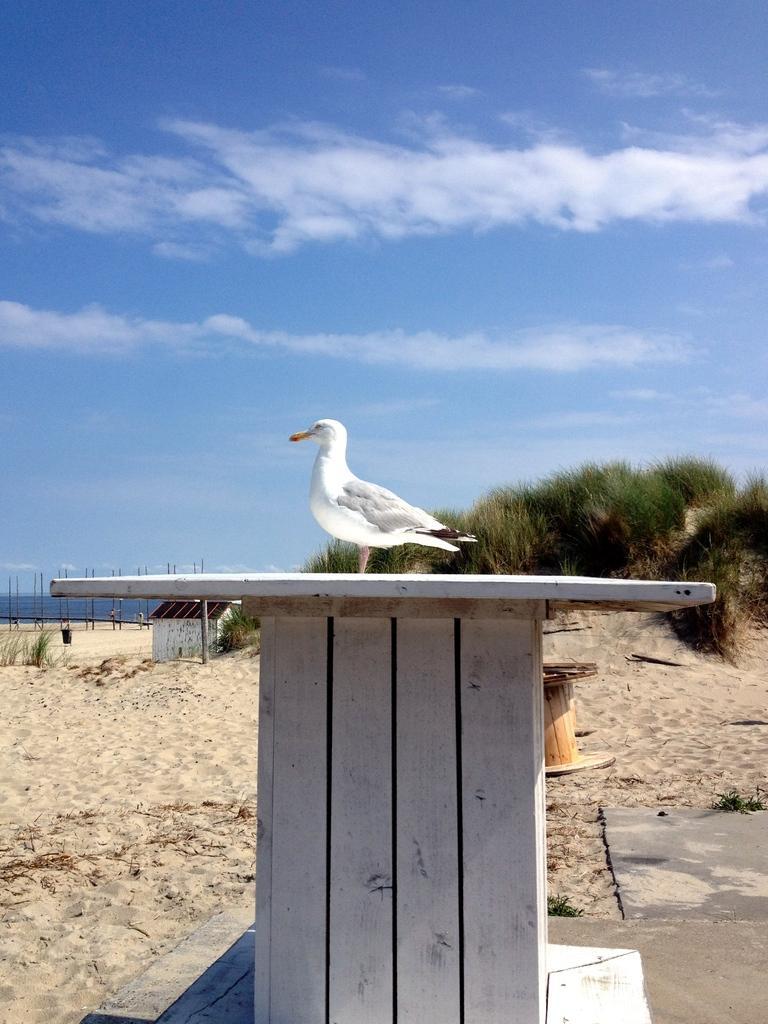How would you summarize this image in a sentence or two? In the image we can see a bird, white in color and here we can see a wooden object. Everywhere there is sand, we can even see grass, building and cloudy pale blue sky. 